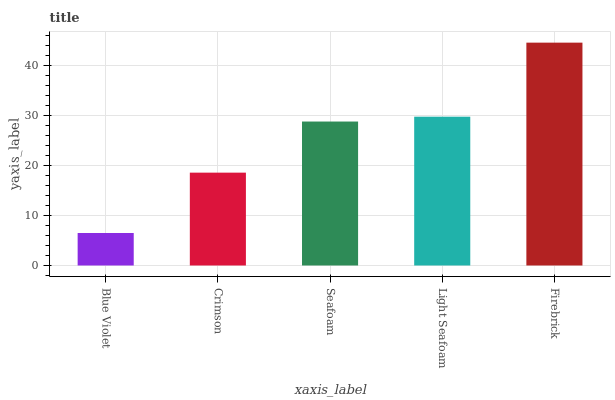Is Blue Violet the minimum?
Answer yes or no. Yes. Is Firebrick the maximum?
Answer yes or no. Yes. Is Crimson the minimum?
Answer yes or no. No. Is Crimson the maximum?
Answer yes or no. No. Is Crimson greater than Blue Violet?
Answer yes or no. Yes. Is Blue Violet less than Crimson?
Answer yes or no. Yes. Is Blue Violet greater than Crimson?
Answer yes or no. No. Is Crimson less than Blue Violet?
Answer yes or no. No. Is Seafoam the high median?
Answer yes or no. Yes. Is Seafoam the low median?
Answer yes or no. Yes. Is Light Seafoam the high median?
Answer yes or no. No. Is Light Seafoam the low median?
Answer yes or no. No. 